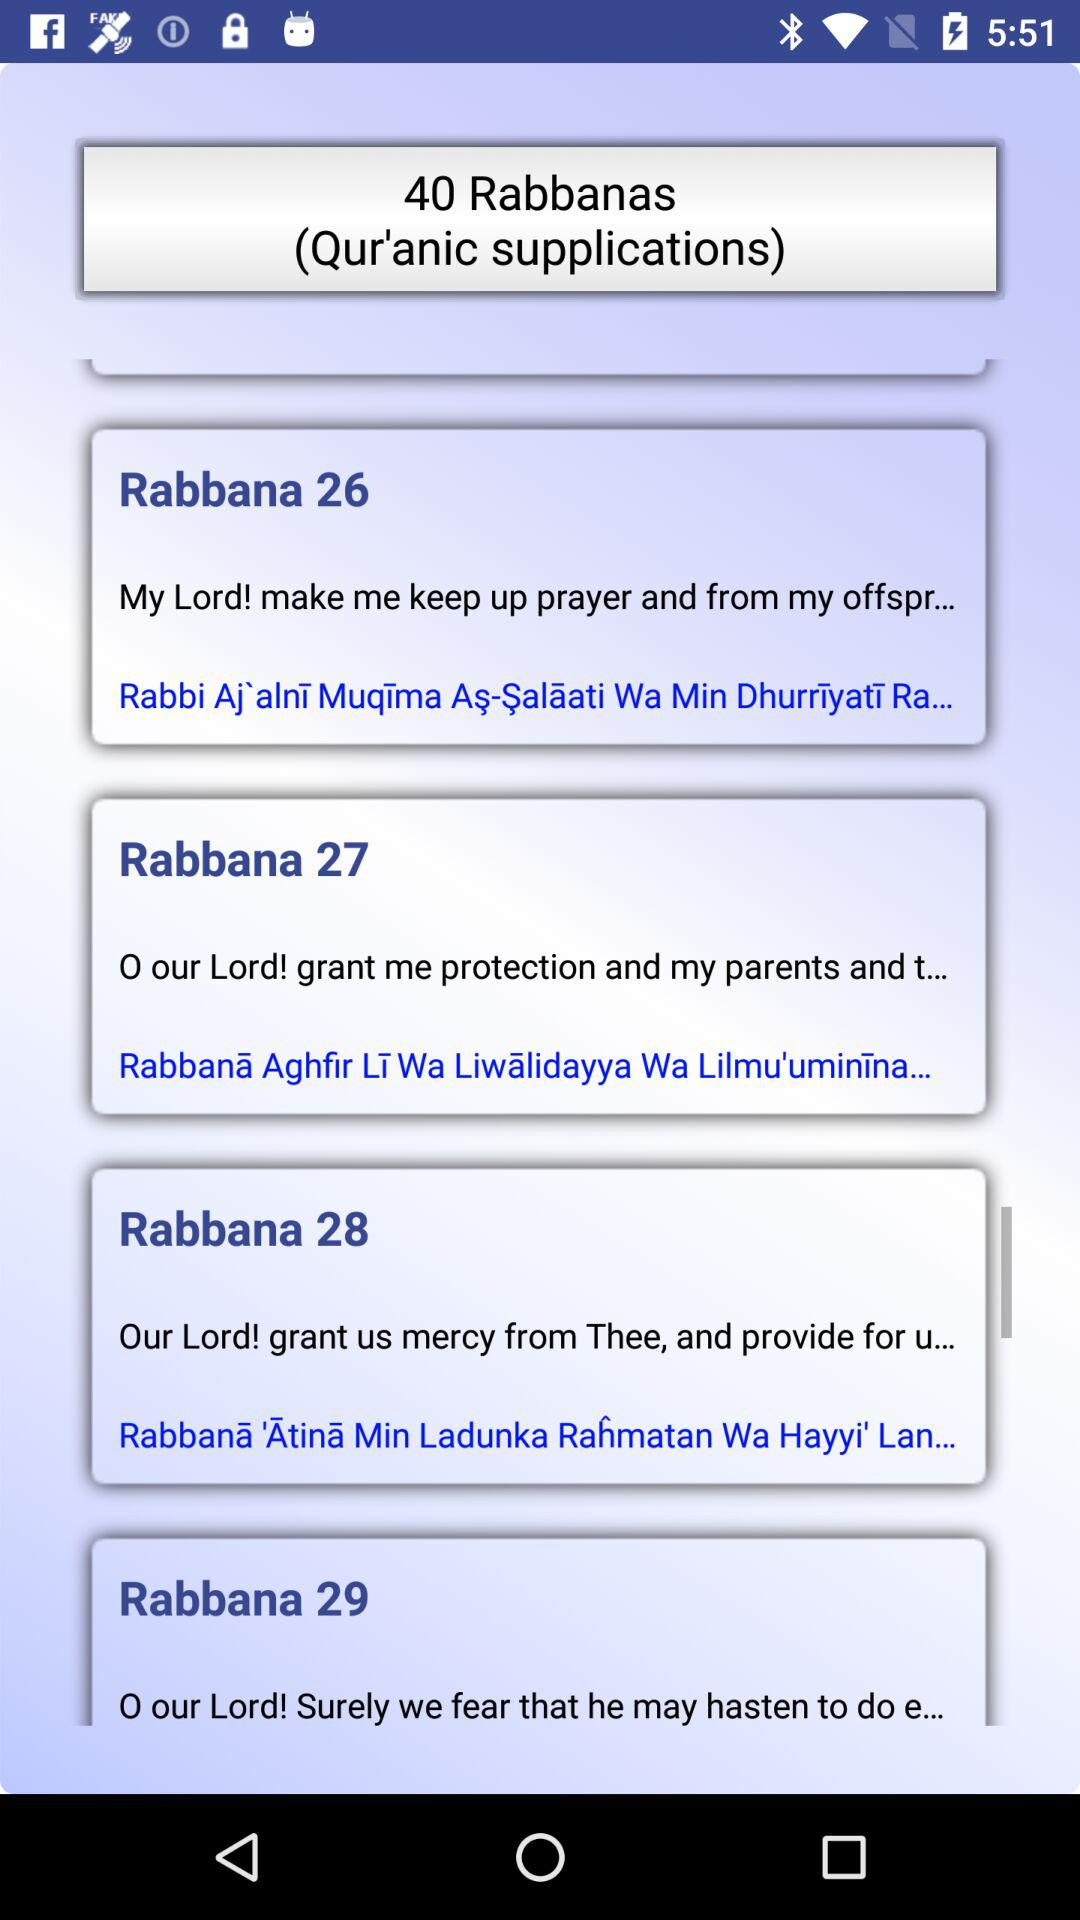What is "Rabbana 26"? "Rabbana 26" is "My Lord! make me keep up prayer and from my offspr...". 